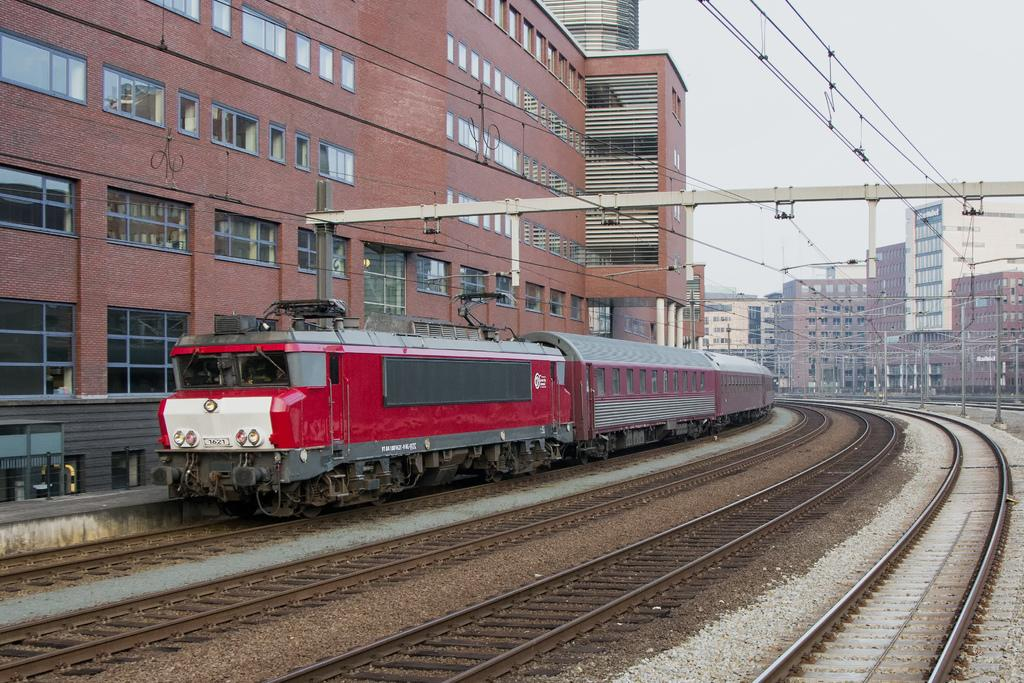What can be seen on the tracks in the image? There is a train on the tracks in the image. What is visible in the background of the image? There are buildings and poles with wires in the background of the image. What is visible at the top of the image? The sky is visible at the top of the image. Can you see a stranger holding a spade in the sand in the image? There is no stranger, spade, or sand present in the image. The image features tracks, a train, buildings, poles with wires, and the sky. 